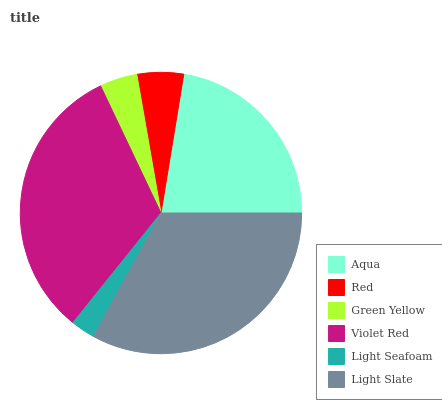Is Light Seafoam the minimum?
Answer yes or no. Yes. Is Light Slate the maximum?
Answer yes or no. Yes. Is Red the minimum?
Answer yes or no. No. Is Red the maximum?
Answer yes or no. No. Is Aqua greater than Red?
Answer yes or no. Yes. Is Red less than Aqua?
Answer yes or no. Yes. Is Red greater than Aqua?
Answer yes or no. No. Is Aqua less than Red?
Answer yes or no. No. Is Aqua the high median?
Answer yes or no. Yes. Is Red the low median?
Answer yes or no. Yes. Is Violet Red the high median?
Answer yes or no. No. Is Light Slate the low median?
Answer yes or no. No. 